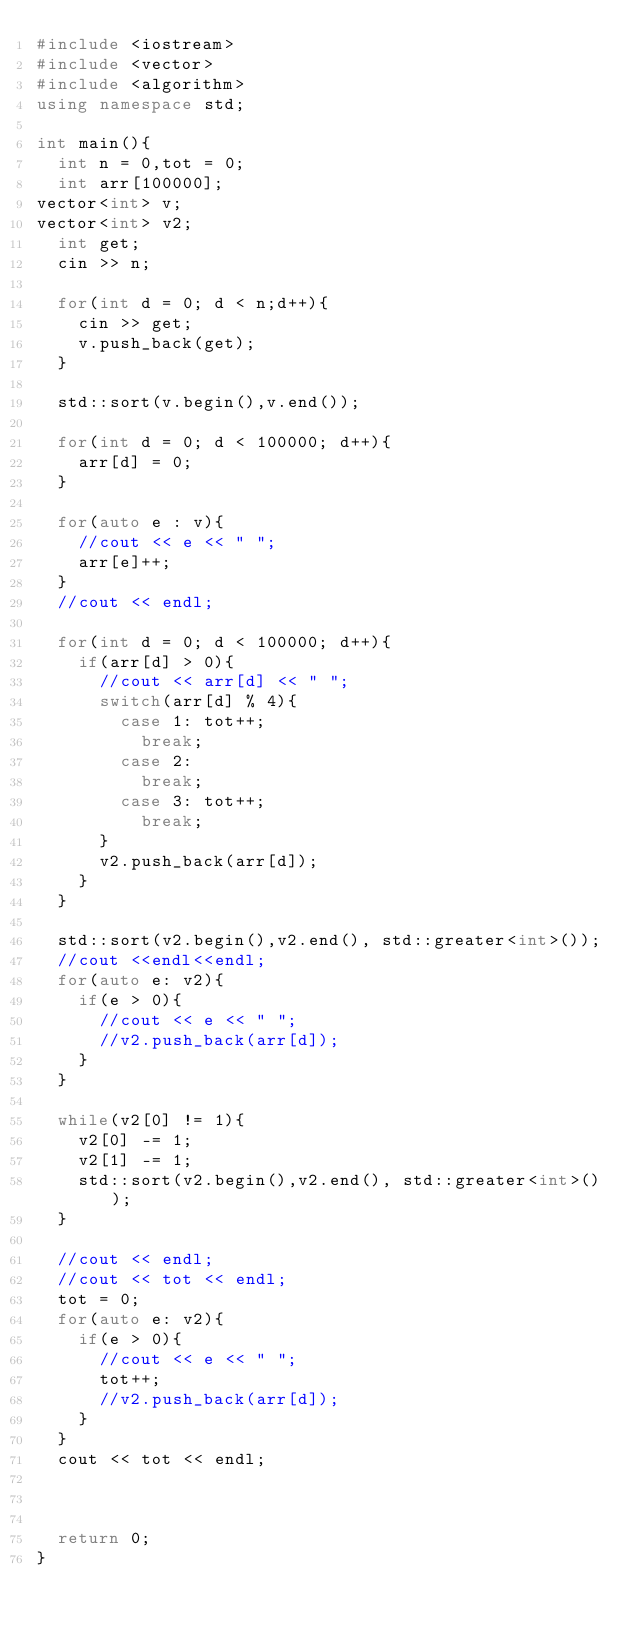Convert code to text. <code><loc_0><loc_0><loc_500><loc_500><_C++_>#include <iostream>
#include <vector>
#include <algorithm>
using namespace std;

int main(){
	int n = 0,tot = 0;
	int arr[100000];
vector<int> v;
vector<int> v2;
	int get;
	cin >> n;

	for(int d = 0; d < n;d++){
		cin >> get;
		v.push_back(get);
	}

	std::sort(v.begin(),v.end());

	for(int d = 0; d < 100000; d++){
		arr[d] = 0;
	}

	for(auto e : v){
		//cout << e << " ";
		arr[e]++;
	}
	//cout << endl;

	for(int d = 0; d < 100000; d++){
		if(arr[d] > 0){
			//cout << arr[d] << " ";
			switch(arr[d] % 4){
				case 1: tot++;
					break;
				case 2: 
					break;
				case 3: tot++;
					break;
			}
			v2.push_back(arr[d]);
		}
	}

	std::sort(v2.begin(),v2.end(), std::greater<int>());
	//cout <<endl<<endl;
	for(auto e: v2){
		if(e > 0){
			//cout << e << " ";
			//v2.push_back(arr[d]);
		}
	}
	
	while(v2[0] != 1){
		v2[0] -= 1;
		v2[1] -= 1;
		std::sort(v2.begin(),v2.end(), std::greater<int>());
	}

	//cout << endl;
	//cout << tot << endl;
	tot = 0;
	for(auto e: v2){
		if(e > 0){
			//cout << e << " ";
			tot++;
			//v2.push_back(arr[d]);
		}
	}
	cout << tot << endl;
	


	return 0;
}</code> 